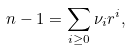<formula> <loc_0><loc_0><loc_500><loc_500>n - 1 = \sum _ { i \geq 0 } \nu _ { i } r ^ { i } ,</formula> 